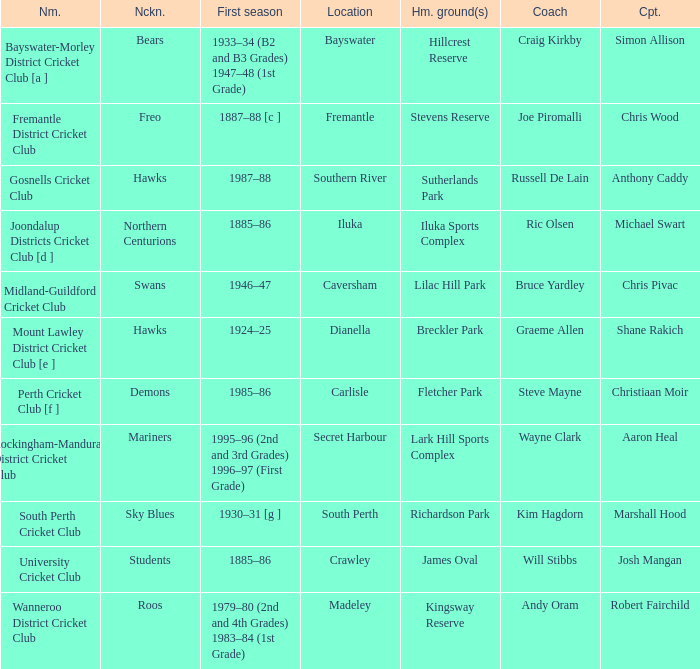What is the location for the club with the nickname the bears? Bayswater. 